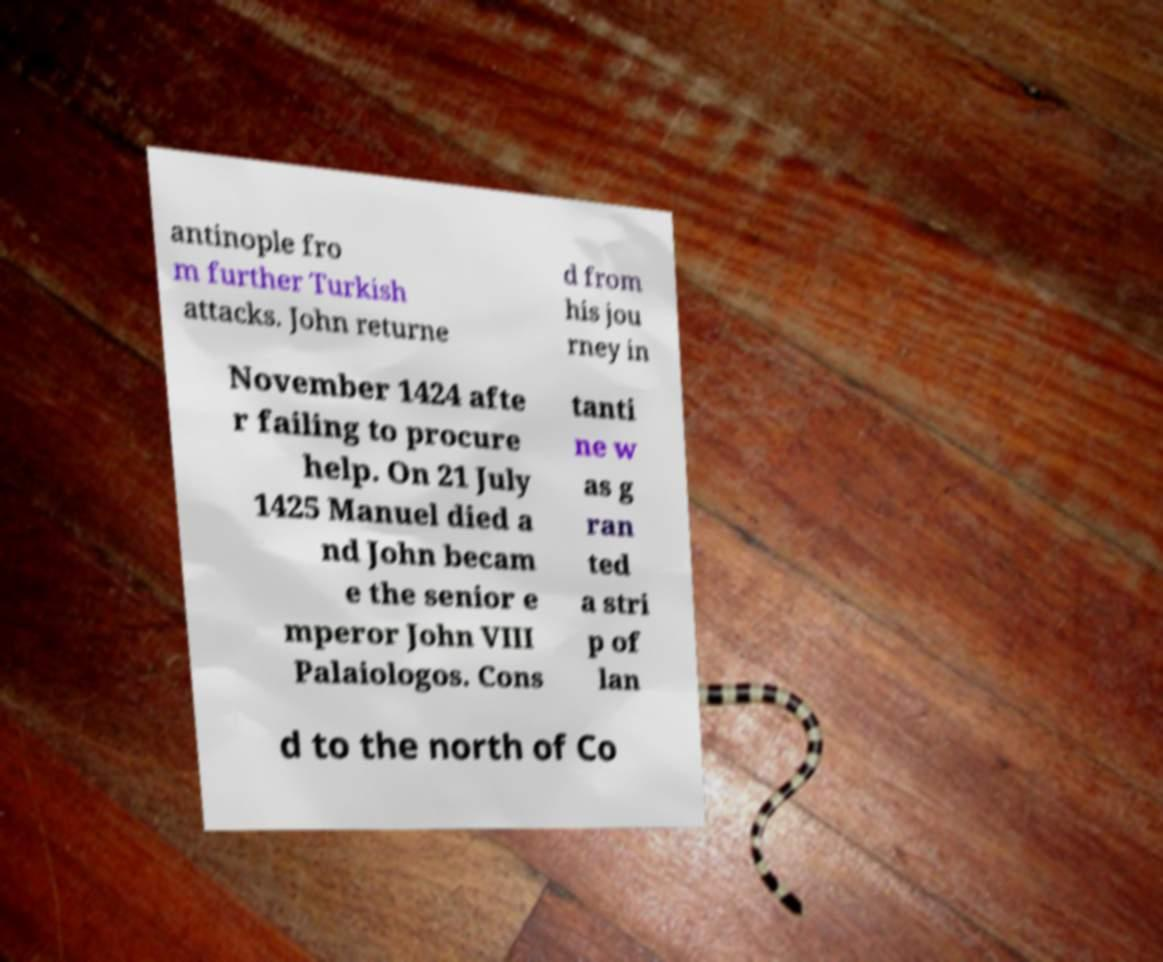What messages or text are displayed in this image? I need them in a readable, typed format. antinople fro m further Turkish attacks. John returne d from his jou rney in November 1424 afte r failing to procure help. On 21 July 1425 Manuel died a nd John becam e the senior e mperor John VIII Palaiologos. Cons tanti ne w as g ran ted a stri p of lan d to the north of Co 